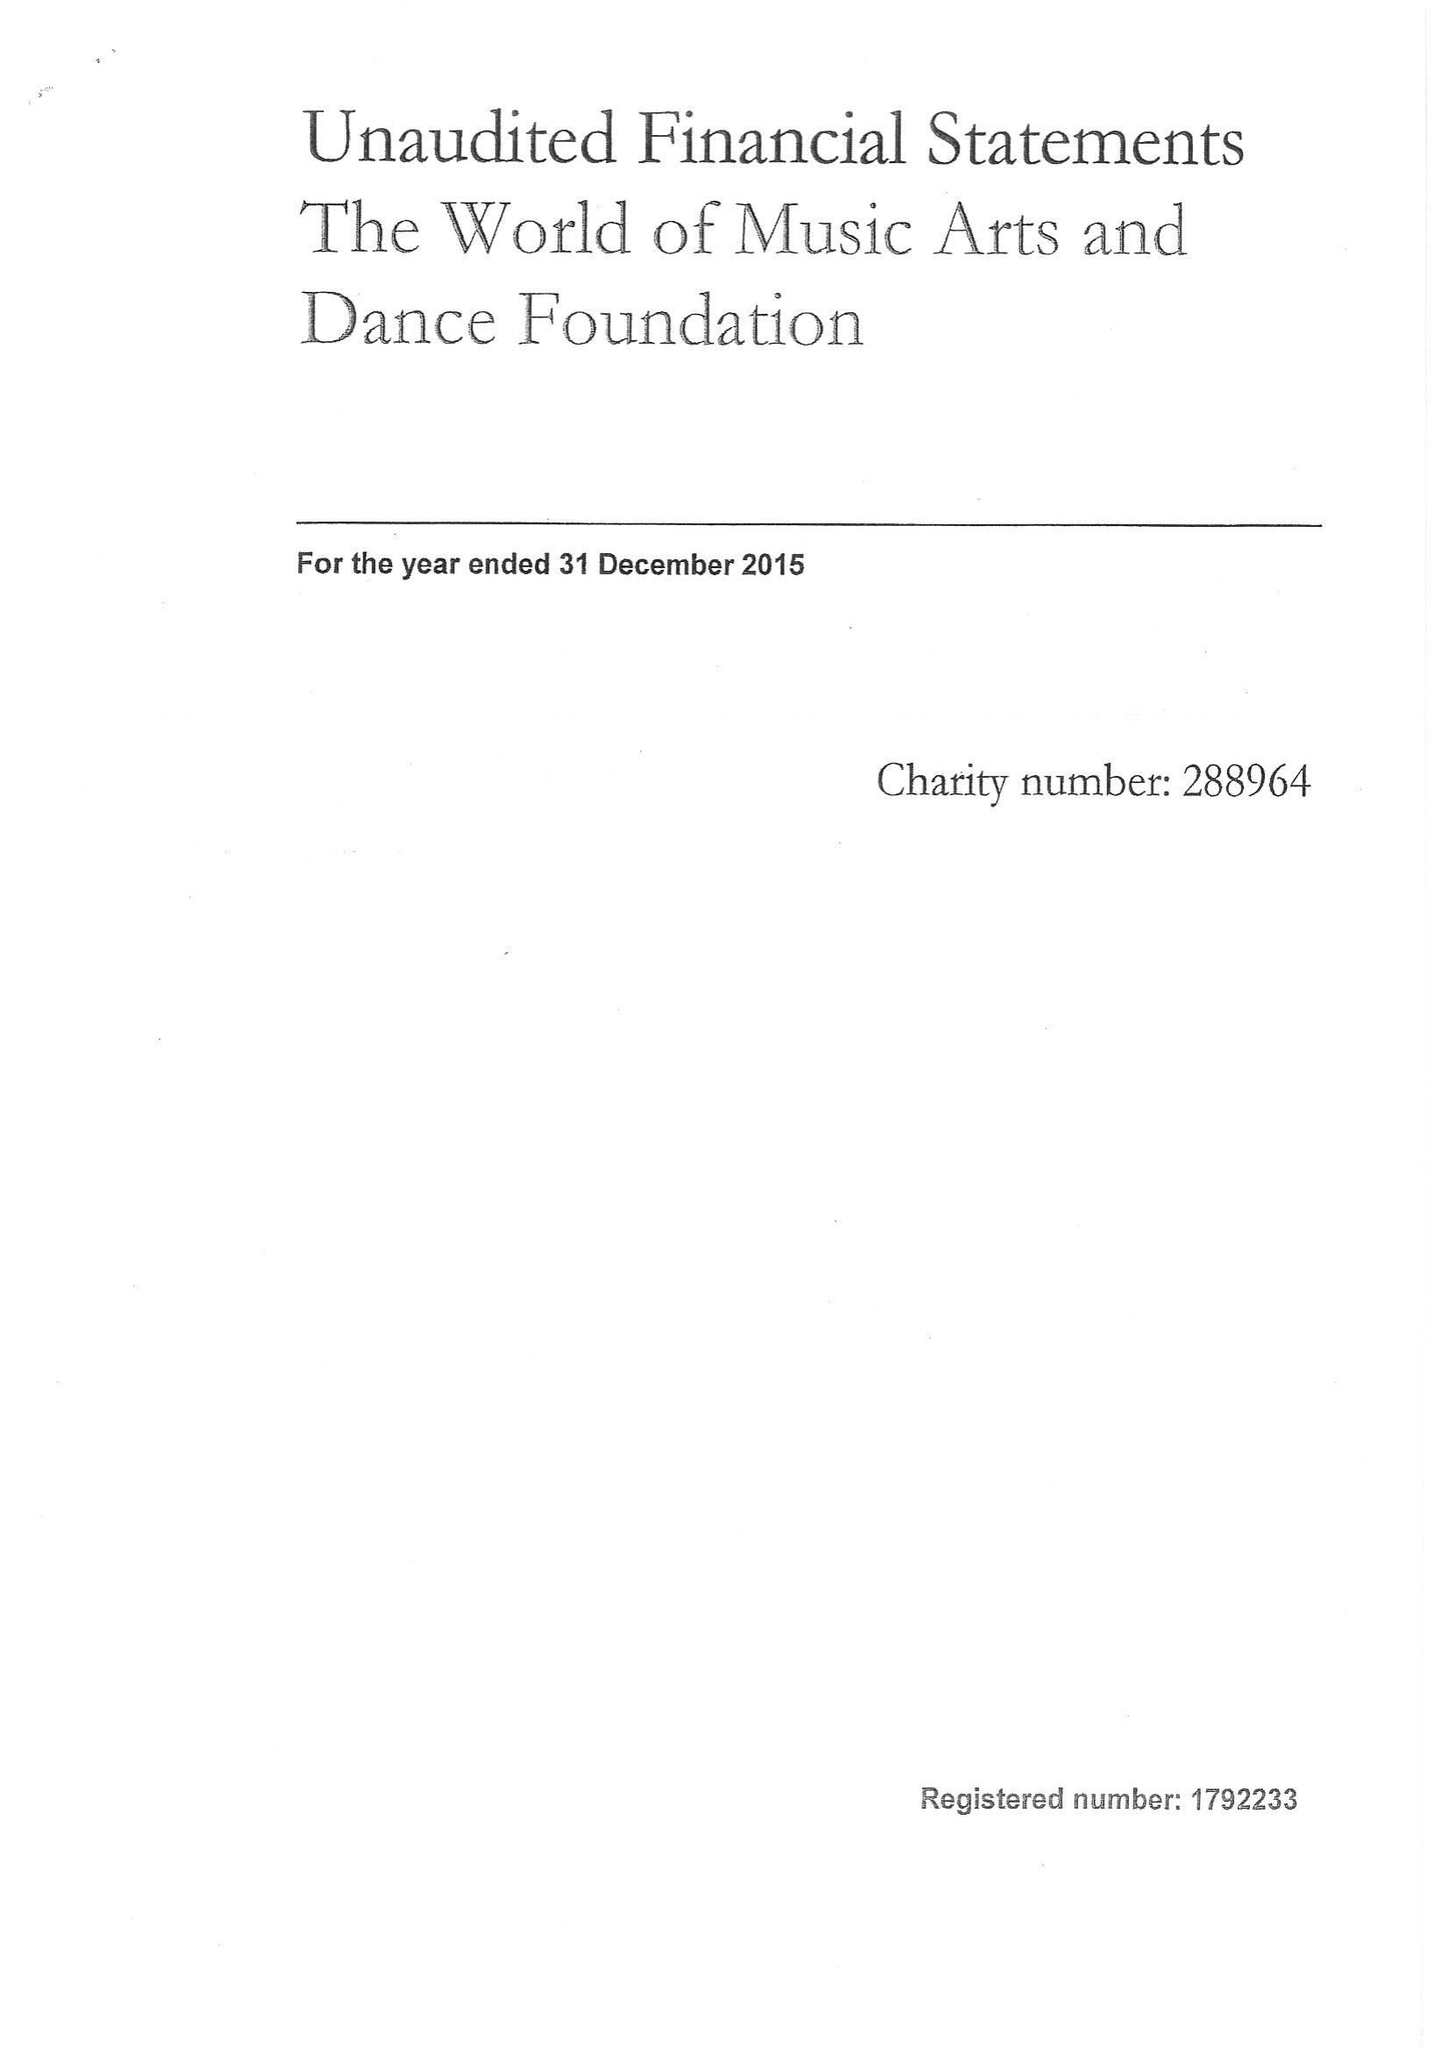What is the value for the spending_annually_in_british_pounds?
Answer the question using a single word or phrase. 50326.00 